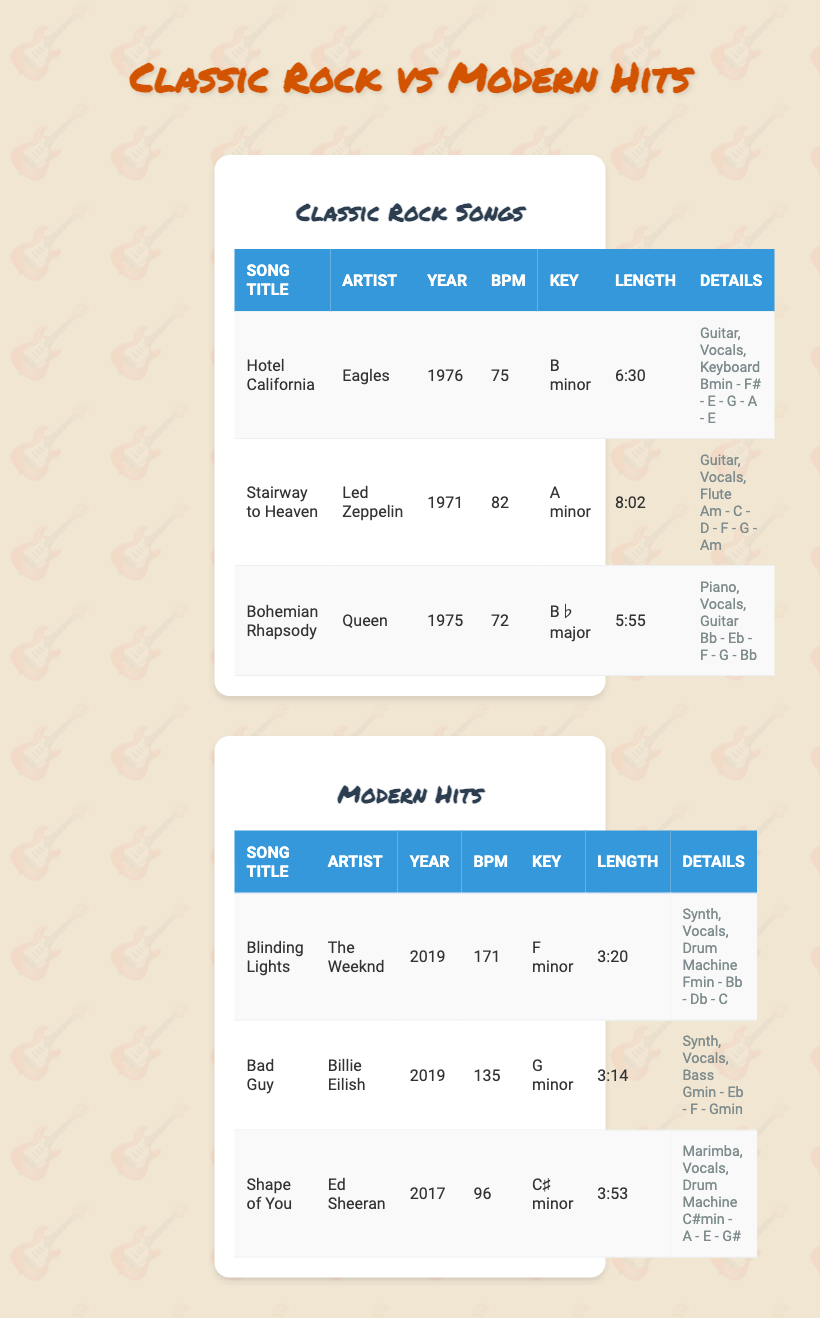What is the BPM of "Stairway to Heaven"? The BPM (beats per minute) of "Stairway to Heaven," which is listed in the Classic Rock Songs table, is 82.
Answer: 82 What is the song with the longest length in the Classic Rock Songs? By checking the lengths of the songs in the Classic Rock category, "Stairway to Heaven" has a length of 8:02, making it the longest song.
Answer: Stairway to Heaven Which song was released first, "Hotel California" or "Blinding Lights"? "Hotel California" was released in 1976, while "Blinding Lights" was released in 2019. Since 1976 is earlier than 2019, "Hotel California" was released first.
Answer: Hotel California What is the average length of the songs in the Modern Hits category? The lengths of the songs are 3:20, 3:14, and 3:53 which converts to minutes as 3.33, 3.23, and 3.88 respectively. The average length is (3.33 + 3.23 + 3.88) / 3 = 3.48 minutes.
Answer: 3.48 minutes Is "Bohemian Rhapsody" faster than "Bad Guy"? "Bohemian Rhapsody" has a BPM of 72 and "Bad Guy" has a BPM of 135. Since 72 is less than 135, "Bohemian Rhapsody" is not faster than "Bad Guy."
Answer: No Which song features the instrument "Synth"? The table indicates that "Blinding Lights" and "Bad Guy" both feature "Synth" as one of their main instruments.
Answer: Blinding Lights and Bad Guy What chord progression is used in "Shape of You"? According to the Modern Hits table, "Shape of You" uses the chord progression C#min - A - E - G#.
Answer: C#min - A - E - G# What is the difference in BPM between the fastest and slowest songs in this comparison? The fastest song is "Blinding Lights" with a BPM of 171, while the slowest in Classic Rock is "Bohemian Rhapsody" with a BPM of 72. The difference in BPM is 171 - 72 = 99.
Answer: 99 Which artist has the most songs listed? In the tables, "Eagles," "Led Zeppelin," and "Queen" each have one song in Classic Rock, while "The Weeknd," "Billie Eilish," and "Ed Sheeran" each have one song in Modern Hits. All artists listed have one song, so there is a tie.
Answer: No artist has the most songs; all have one 